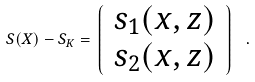Convert formula to latex. <formula><loc_0><loc_0><loc_500><loc_500>S ( X ) - S _ { K } = \left \lgroup \begin{array} { c } s _ { 1 } ( x , z ) \\ s _ { 2 } ( x , z ) \end{array} \right \rgroup \ .</formula> 